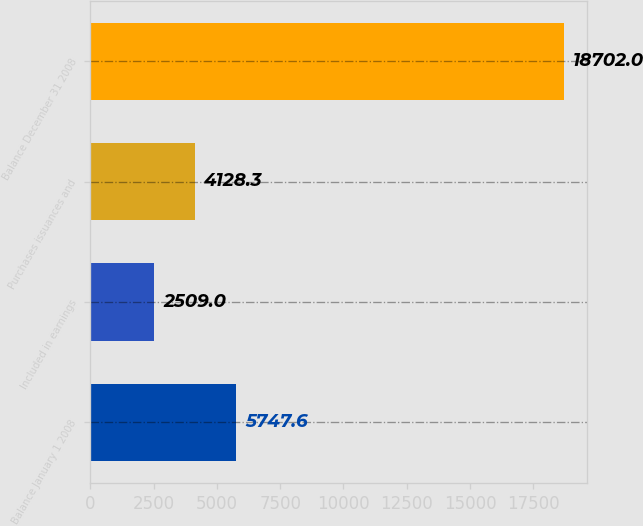<chart> <loc_0><loc_0><loc_500><loc_500><bar_chart><fcel>Balance January 1 2008<fcel>Included in earnings<fcel>Purchases issuances and<fcel>Balance December 31 2008<nl><fcel>5747.6<fcel>2509<fcel>4128.3<fcel>18702<nl></chart> 